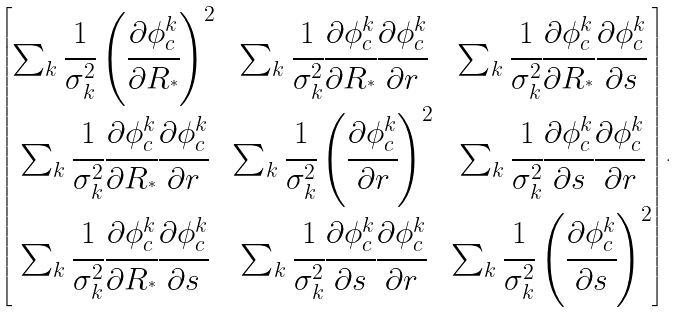Convert formula to latex. <formula><loc_0><loc_0><loc_500><loc_500>\begin{bmatrix} \sum _ { k } { \cfrac { 1 } { { \sigma } _ { k } ^ { 2 } } \left ( \cfrac { \partial \phi _ { c } ^ { k } } { \partial R _ { ^ { * } } } \right ) ^ { 2 } } & \sum _ { k } { \cfrac { 1 } { { \sigma } _ { k } ^ { 2 } } \cfrac { \partial \phi _ { c } ^ { k } } { \partial R _ { ^ { * } } } \cfrac { \partial \phi _ { c } ^ { k } } { \partial { r } } } & \sum _ { k } { \cfrac { 1 } { { \sigma } _ { k } ^ { 2 } } \cfrac { \partial \phi _ { c } ^ { k } } { \partial R _ { ^ { * } } } \cfrac { \partial \phi _ { c } ^ { k } } { \partial { s } } } \\ \sum _ { k } { \cfrac { 1 } { { \sigma } _ { k } ^ { 2 } } \cfrac { \partial \phi _ { c } ^ { k } } { \partial R _ { ^ { * } } } \cfrac { \partial \phi _ { c } ^ { k } } { \partial { r } } } & \sum _ { k } { \cfrac { 1 } { { \sigma } _ { k } ^ { 2 } } \left ( \cfrac { \partial \phi _ { c } ^ { k } } { \partial r } \right ) ^ { 2 } } & \sum _ { k } { \cfrac { 1 } { { \sigma } _ { k } ^ { 2 } } \cfrac { \partial \phi _ { c } ^ { k } } { \partial s } \cfrac { \partial \phi _ { c } ^ { k } } { \partial { r } } } \\ \sum _ { k } { \cfrac { 1 } { { \sigma } _ { k } ^ { 2 } } \cfrac { \partial \phi _ { c } ^ { k } } { \partial R _ { ^ { * } } } \cfrac { \partial \phi _ { c } ^ { k } } { \partial { s } } } & \sum _ { k } { \cfrac { 1 } { { \sigma } _ { k } ^ { 2 } } \cfrac { \partial \phi _ { c } ^ { k } } { \partial s } \cfrac { \partial \phi _ { c } ^ { k } } { \partial { r } } } & \sum _ { k } { \cfrac { 1 } { { \sigma } _ { k } ^ { 2 } } \left ( \cfrac { \partial \phi _ { c } ^ { k } } { \partial { s } } \right ) ^ { 2 } } \end{bmatrix} .</formula> 